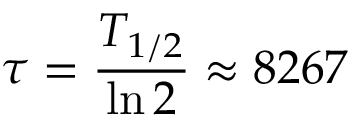<formula> <loc_0><loc_0><loc_500><loc_500>\tau = { \frac { T _ { 1 / 2 } } { \ln 2 } } \approx 8 2 6 7</formula> 